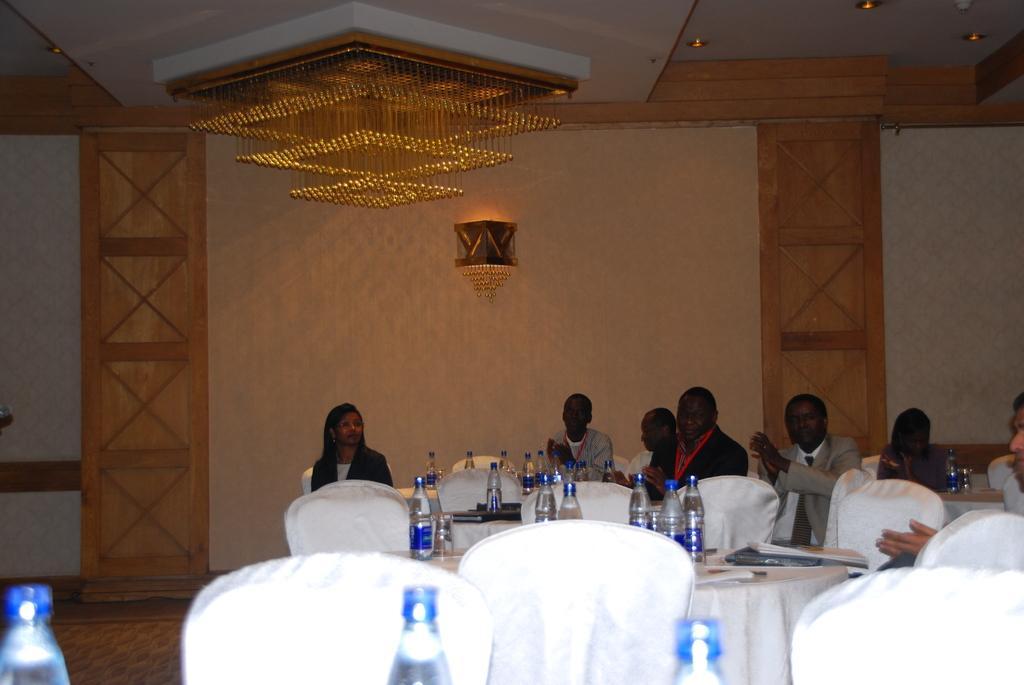Describe this image in one or two sentences. There are some persons sitting on the chairs, and we can see there are some bottles kept on the tables and there are some chairs at the bottom of this image, and there is a wall in the background. There is a chandelier at the top of this image. 